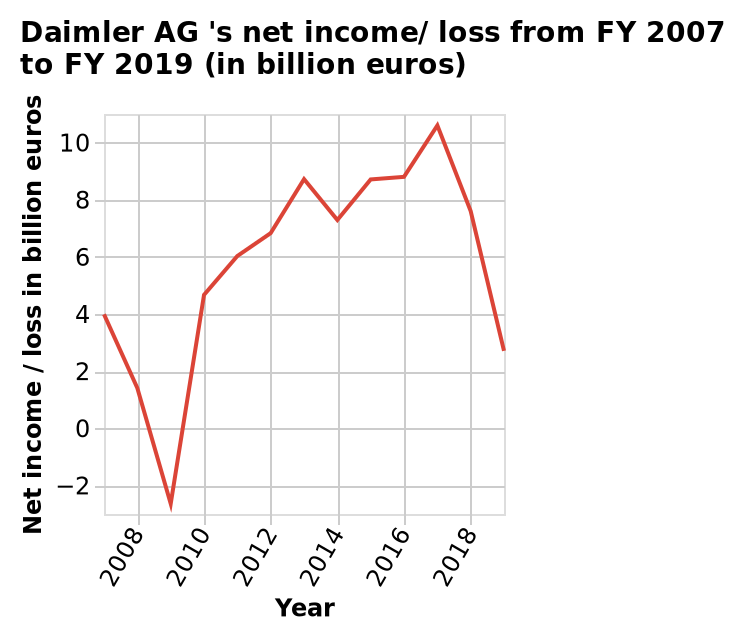<image>
please summary the statistics and relations of the chart Daimler AG 's net income/ loss saw it's biggest loss between 2008 and 2010. Daimler AG 's net income/ loss saw its highest net income 2016 and 2018. What does the y-axis represent in the diagram? The y-axis represents the net income/loss in billion euros. Did Daimler AG's net income/loss improve or worsen between 2016 and 2018? Daimler AG's net income/loss improved between 2016 and 2018. 